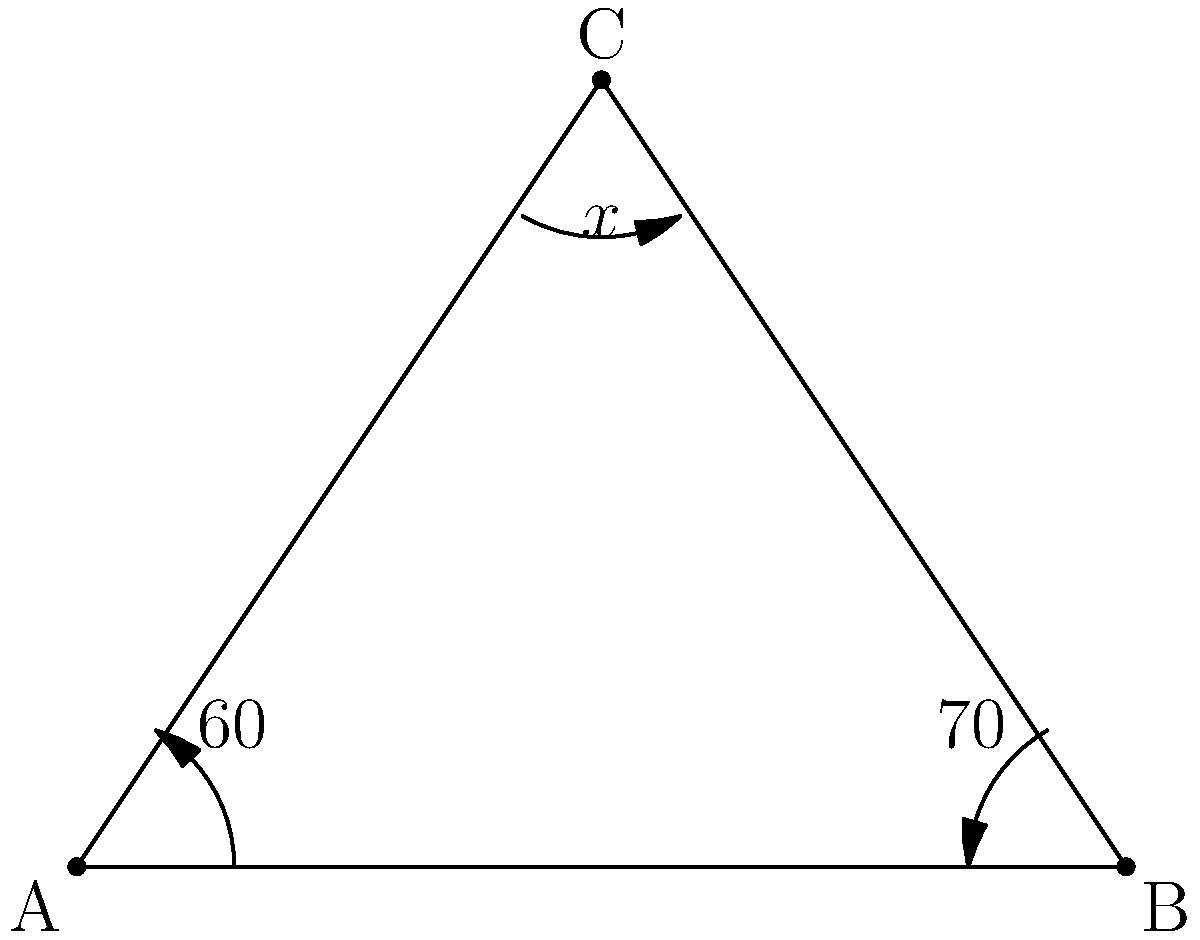On the surface of a neutron star, where space is highly curved due to intense gravitational effects, a triangle ABC is formed. The internal angles at vertices A and B are measured to be 60° and 70° respectively. What is the measure of the internal angle at vertex C, denoted as $x°$? To solve this problem, we need to consider the principles of non-Euclidean geometry that apply on the curved surface of a neutron star:

1) In non-Euclidean geometry on a curved surface with positive curvature (like a sphere or neutron star surface), the sum of internal angles in a triangle is always greater than 180°.

2) The excess angle (difference between the sum of angles and 180°) is proportional to the area of the triangle and the curvature of the surface.

3) Let's denote the sum of the internal angles as S. We know that:
   $S = 60° + 70° + x° > 180°$

4) We can't determine the exact value of x without knowing the precise curvature of the neutron star's surface and the size of the triangle. However, we can conclude that:
   $x > 180° - (60° + 70°) = 50°$

5) This means that the angle at C must be larger than 50°, which would be the case in Euclidean geometry.

6) The actual value of x could be significantly larger than 50°, depending on how curved the surface is at that location on the neutron star.

Therefore, while we can't provide an exact value for x, we can definitively state that it must be greater than 50°.
Answer: $x > 50°$ 